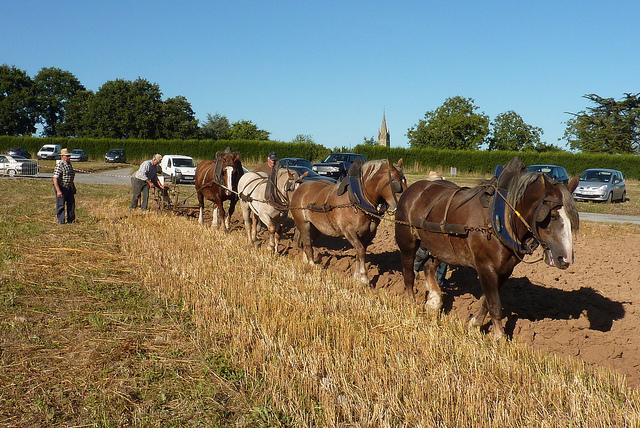What are the horses wearing around their necks?
Quick response, please. Reins. Where is this farm?
Be succinct. Pennsylvania. Where are the cars parked?
Give a very brief answer. Background. 